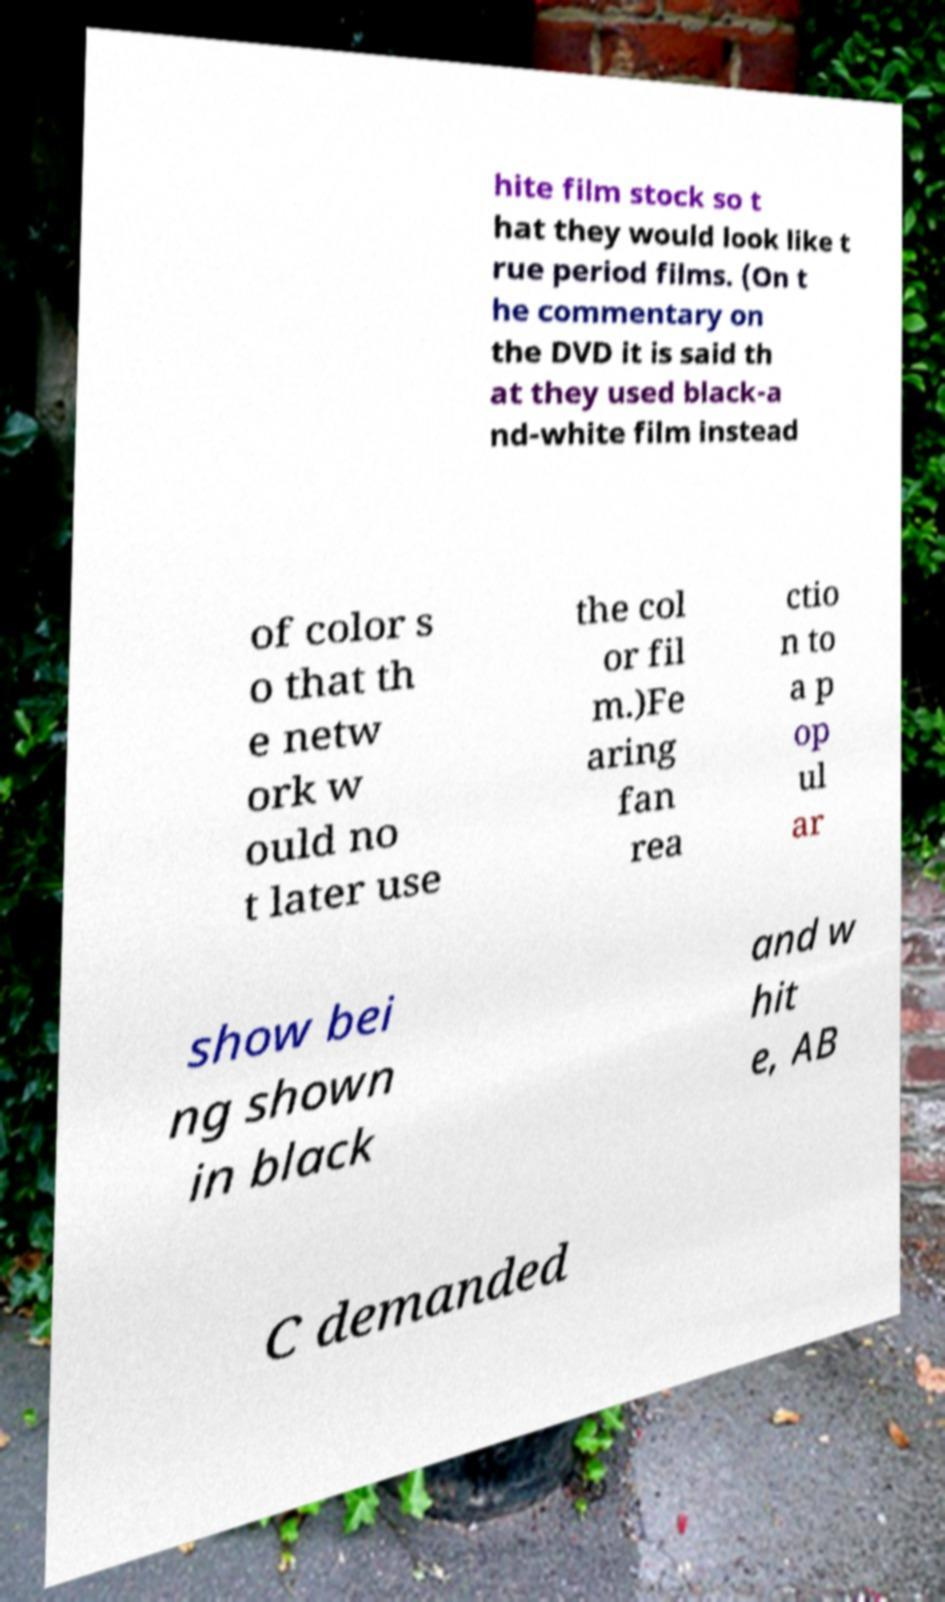Please identify and transcribe the text found in this image. hite film stock so t hat they would look like t rue period films. (On t he commentary on the DVD it is said th at they used black-a nd-white film instead of color s o that th e netw ork w ould no t later use the col or fil m.)Fe aring fan rea ctio n to a p op ul ar show bei ng shown in black and w hit e, AB C demanded 